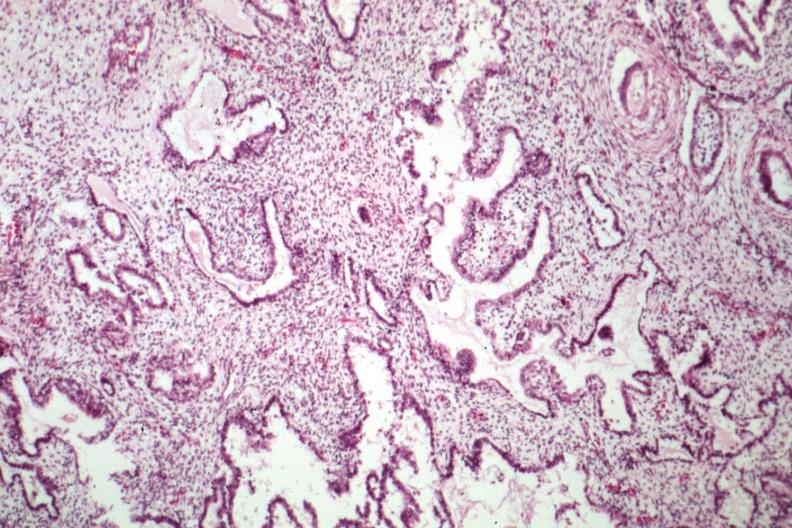does this image show epithelial component resembling endometrium?
Answer the question using a single word or phrase. Yes 